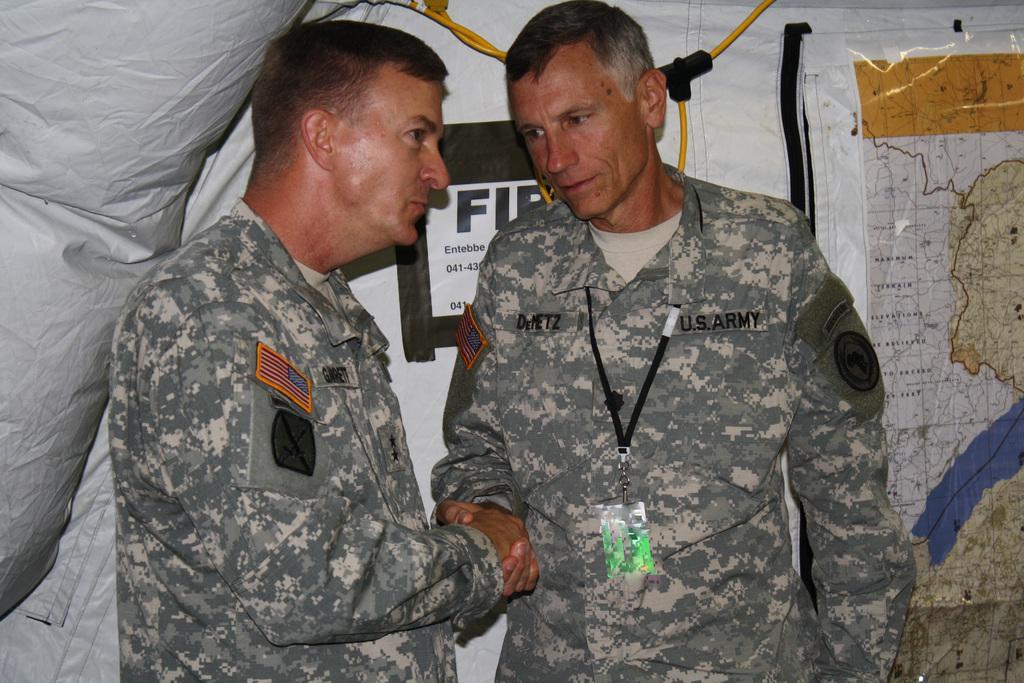Please provide a concise description of this image. In the center of the image we can see two mans are standing. In the background of the image we can see banner, wire and poster. 